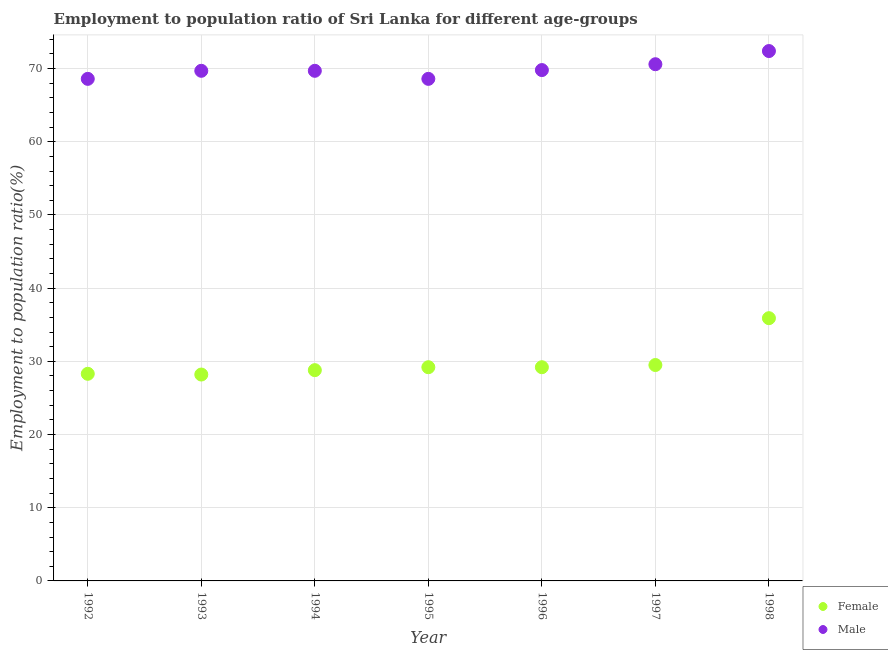How many different coloured dotlines are there?
Provide a short and direct response. 2. What is the employment to population ratio(male) in 1998?
Offer a terse response. 72.4. Across all years, what is the maximum employment to population ratio(female)?
Provide a succinct answer. 35.9. Across all years, what is the minimum employment to population ratio(female)?
Your answer should be compact. 28.2. In which year was the employment to population ratio(male) minimum?
Provide a succinct answer. 1992. What is the total employment to population ratio(male) in the graph?
Ensure brevity in your answer.  489.4. What is the difference between the employment to population ratio(male) in 1996 and that in 1998?
Give a very brief answer. -2.6. What is the difference between the employment to population ratio(female) in 1998 and the employment to population ratio(male) in 1995?
Your answer should be compact. -32.7. What is the average employment to population ratio(female) per year?
Provide a succinct answer. 29.87. In the year 1993, what is the difference between the employment to population ratio(female) and employment to population ratio(male)?
Offer a very short reply. -41.5. What is the ratio of the employment to population ratio(male) in 1993 to that in 1998?
Keep it short and to the point. 0.96. Is the employment to population ratio(male) in 1997 less than that in 1998?
Offer a very short reply. Yes. What is the difference between the highest and the second highest employment to population ratio(male)?
Make the answer very short. 1.8. What is the difference between the highest and the lowest employment to population ratio(male)?
Your response must be concise. 3.8. Is the sum of the employment to population ratio(female) in 1994 and 1995 greater than the maximum employment to population ratio(male) across all years?
Provide a succinct answer. No. Does the employment to population ratio(female) monotonically increase over the years?
Give a very brief answer. No. Is the employment to population ratio(female) strictly less than the employment to population ratio(male) over the years?
Provide a succinct answer. Yes. What is the difference between two consecutive major ticks on the Y-axis?
Provide a short and direct response. 10. Are the values on the major ticks of Y-axis written in scientific E-notation?
Your answer should be very brief. No. Does the graph contain any zero values?
Your answer should be compact. No. Does the graph contain grids?
Provide a short and direct response. Yes. Where does the legend appear in the graph?
Keep it short and to the point. Bottom right. How are the legend labels stacked?
Offer a very short reply. Vertical. What is the title of the graph?
Ensure brevity in your answer.  Employment to population ratio of Sri Lanka for different age-groups. Does "All education staff compensation" appear as one of the legend labels in the graph?
Your answer should be compact. No. What is the label or title of the X-axis?
Give a very brief answer. Year. What is the label or title of the Y-axis?
Give a very brief answer. Employment to population ratio(%). What is the Employment to population ratio(%) in Female in 1992?
Provide a succinct answer. 28.3. What is the Employment to population ratio(%) in Male in 1992?
Your response must be concise. 68.6. What is the Employment to population ratio(%) in Female in 1993?
Offer a terse response. 28.2. What is the Employment to population ratio(%) of Male in 1993?
Your response must be concise. 69.7. What is the Employment to population ratio(%) in Female in 1994?
Ensure brevity in your answer.  28.8. What is the Employment to population ratio(%) of Male in 1994?
Keep it short and to the point. 69.7. What is the Employment to population ratio(%) in Female in 1995?
Ensure brevity in your answer.  29.2. What is the Employment to population ratio(%) in Male in 1995?
Provide a short and direct response. 68.6. What is the Employment to population ratio(%) in Female in 1996?
Ensure brevity in your answer.  29.2. What is the Employment to population ratio(%) in Male in 1996?
Your response must be concise. 69.8. What is the Employment to population ratio(%) in Female in 1997?
Offer a terse response. 29.5. What is the Employment to population ratio(%) of Male in 1997?
Make the answer very short. 70.6. What is the Employment to population ratio(%) in Female in 1998?
Provide a succinct answer. 35.9. What is the Employment to population ratio(%) of Male in 1998?
Provide a short and direct response. 72.4. Across all years, what is the maximum Employment to population ratio(%) in Female?
Provide a succinct answer. 35.9. Across all years, what is the maximum Employment to population ratio(%) in Male?
Keep it short and to the point. 72.4. Across all years, what is the minimum Employment to population ratio(%) of Female?
Keep it short and to the point. 28.2. Across all years, what is the minimum Employment to population ratio(%) of Male?
Provide a short and direct response. 68.6. What is the total Employment to population ratio(%) of Female in the graph?
Keep it short and to the point. 209.1. What is the total Employment to population ratio(%) of Male in the graph?
Provide a succinct answer. 489.4. What is the difference between the Employment to population ratio(%) of Female in 1992 and that in 1993?
Your answer should be compact. 0.1. What is the difference between the Employment to population ratio(%) of Male in 1992 and that in 1993?
Offer a very short reply. -1.1. What is the difference between the Employment to population ratio(%) of Female in 1992 and that in 1994?
Offer a terse response. -0.5. What is the difference between the Employment to population ratio(%) of Female in 1992 and that in 1996?
Make the answer very short. -0.9. What is the difference between the Employment to population ratio(%) in Female in 1992 and that in 1997?
Provide a succinct answer. -1.2. What is the difference between the Employment to population ratio(%) of Male in 1992 and that in 1997?
Provide a succinct answer. -2. What is the difference between the Employment to population ratio(%) in Female in 1992 and that in 1998?
Keep it short and to the point. -7.6. What is the difference between the Employment to population ratio(%) of Female in 1993 and that in 1995?
Provide a succinct answer. -1. What is the difference between the Employment to population ratio(%) in Male in 1993 and that in 1996?
Offer a terse response. -0.1. What is the difference between the Employment to population ratio(%) in Male in 1993 and that in 1997?
Provide a short and direct response. -0.9. What is the difference between the Employment to population ratio(%) of Female in 1993 and that in 1998?
Ensure brevity in your answer.  -7.7. What is the difference between the Employment to population ratio(%) of Male in 1993 and that in 1998?
Keep it short and to the point. -2.7. What is the difference between the Employment to population ratio(%) in Male in 1994 and that in 1995?
Keep it short and to the point. 1.1. What is the difference between the Employment to population ratio(%) in Male in 1994 and that in 1997?
Your answer should be compact. -0.9. What is the difference between the Employment to population ratio(%) of Male in 1994 and that in 1998?
Offer a very short reply. -2.7. What is the difference between the Employment to population ratio(%) of Female in 1995 and that in 1997?
Provide a succinct answer. -0.3. What is the difference between the Employment to population ratio(%) of Female in 1995 and that in 1998?
Provide a short and direct response. -6.7. What is the difference between the Employment to population ratio(%) of Male in 1995 and that in 1998?
Make the answer very short. -3.8. What is the difference between the Employment to population ratio(%) of Male in 1996 and that in 1997?
Offer a terse response. -0.8. What is the difference between the Employment to population ratio(%) of Male in 1996 and that in 1998?
Offer a terse response. -2.6. What is the difference between the Employment to population ratio(%) of Male in 1997 and that in 1998?
Your response must be concise. -1.8. What is the difference between the Employment to population ratio(%) of Female in 1992 and the Employment to population ratio(%) of Male in 1993?
Give a very brief answer. -41.4. What is the difference between the Employment to population ratio(%) in Female in 1992 and the Employment to population ratio(%) in Male in 1994?
Keep it short and to the point. -41.4. What is the difference between the Employment to population ratio(%) of Female in 1992 and the Employment to population ratio(%) of Male in 1995?
Offer a terse response. -40.3. What is the difference between the Employment to population ratio(%) in Female in 1992 and the Employment to population ratio(%) in Male in 1996?
Provide a short and direct response. -41.5. What is the difference between the Employment to population ratio(%) in Female in 1992 and the Employment to population ratio(%) in Male in 1997?
Make the answer very short. -42.3. What is the difference between the Employment to population ratio(%) of Female in 1992 and the Employment to population ratio(%) of Male in 1998?
Make the answer very short. -44.1. What is the difference between the Employment to population ratio(%) in Female in 1993 and the Employment to population ratio(%) in Male in 1994?
Ensure brevity in your answer.  -41.5. What is the difference between the Employment to population ratio(%) of Female in 1993 and the Employment to population ratio(%) of Male in 1995?
Offer a terse response. -40.4. What is the difference between the Employment to population ratio(%) in Female in 1993 and the Employment to population ratio(%) in Male in 1996?
Make the answer very short. -41.6. What is the difference between the Employment to population ratio(%) of Female in 1993 and the Employment to population ratio(%) of Male in 1997?
Keep it short and to the point. -42.4. What is the difference between the Employment to population ratio(%) in Female in 1993 and the Employment to population ratio(%) in Male in 1998?
Your response must be concise. -44.2. What is the difference between the Employment to population ratio(%) of Female in 1994 and the Employment to population ratio(%) of Male in 1995?
Make the answer very short. -39.8. What is the difference between the Employment to population ratio(%) of Female in 1994 and the Employment to population ratio(%) of Male in 1996?
Offer a terse response. -41. What is the difference between the Employment to population ratio(%) of Female in 1994 and the Employment to population ratio(%) of Male in 1997?
Provide a succinct answer. -41.8. What is the difference between the Employment to population ratio(%) in Female in 1994 and the Employment to population ratio(%) in Male in 1998?
Your answer should be very brief. -43.6. What is the difference between the Employment to population ratio(%) in Female in 1995 and the Employment to population ratio(%) in Male in 1996?
Your answer should be compact. -40.6. What is the difference between the Employment to population ratio(%) of Female in 1995 and the Employment to population ratio(%) of Male in 1997?
Ensure brevity in your answer.  -41.4. What is the difference between the Employment to population ratio(%) of Female in 1995 and the Employment to population ratio(%) of Male in 1998?
Keep it short and to the point. -43.2. What is the difference between the Employment to population ratio(%) in Female in 1996 and the Employment to population ratio(%) in Male in 1997?
Offer a very short reply. -41.4. What is the difference between the Employment to population ratio(%) in Female in 1996 and the Employment to population ratio(%) in Male in 1998?
Offer a very short reply. -43.2. What is the difference between the Employment to population ratio(%) of Female in 1997 and the Employment to population ratio(%) of Male in 1998?
Your answer should be very brief. -42.9. What is the average Employment to population ratio(%) of Female per year?
Offer a terse response. 29.87. What is the average Employment to population ratio(%) in Male per year?
Your response must be concise. 69.91. In the year 1992, what is the difference between the Employment to population ratio(%) in Female and Employment to population ratio(%) in Male?
Your response must be concise. -40.3. In the year 1993, what is the difference between the Employment to population ratio(%) in Female and Employment to population ratio(%) in Male?
Your response must be concise. -41.5. In the year 1994, what is the difference between the Employment to population ratio(%) in Female and Employment to population ratio(%) in Male?
Your answer should be very brief. -40.9. In the year 1995, what is the difference between the Employment to population ratio(%) of Female and Employment to population ratio(%) of Male?
Offer a terse response. -39.4. In the year 1996, what is the difference between the Employment to population ratio(%) of Female and Employment to population ratio(%) of Male?
Provide a short and direct response. -40.6. In the year 1997, what is the difference between the Employment to population ratio(%) in Female and Employment to population ratio(%) in Male?
Keep it short and to the point. -41.1. In the year 1998, what is the difference between the Employment to population ratio(%) in Female and Employment to population ratio(%) in Male?
Provide a succinct answer. -36.5. What is the ratio of the Employment to population ratio(%) in Female in 1992 to that in 1993?
Make the answer very short. 1. What is the ratio of the Employment to population ratio(%) in Male in 1992 to that in 1993?
Offer a terse response. 0.98. What is the ratio of the Employment to population ratio(%) in Female in 1992 to that in 1994?
Offer a terse response. 0.98. What is the ratio of the Employment to population ratio(%) in Male in 1992 to that in 1994?
Ensure brevity in your answer.  0.98. What is the ratio of the Employment to population ratio(%) in Female in 1992 to that in 1995?
Make the answer very short. 0.97. What is the ratio of the Employment to population ratio(%) in Male in 1992 to that in 1995?
Your response must be concise. 1. What is the ratio of the Employment to population ratio(%) in Female in 1992 to that in 1996?
Offer a very short reply. 0.97. What is the ratio of the Employment to population ratio(%) in Male in 1992 to that in 1996?
Keep it short and to the point. 0.98. What is the ratio of the Employment to population ratio(%) in Female in 1992 to that in 1997?
Provide a succinct answer. 0.96. What is the ratio of the Employment to population ratio(%) in Male in 1992 to that in 1997?
Your answer should be compact. 0.97. What is the ratio of the Employment to population ratio(%) of Female in 1992 to that in 1998?
Make the answer very short. 0.79. What is the ratio of the Employment to population ratio(%) of Male in 1992 to that in 1998?
Make the answer very short. 0.95. What is the ratio of the Employment to population ratio(%) of Female in 1993 to that in 1994?
Offer a terse response. 0.98. What is the ratio of the Employment to population ratio(%) of Male in 1993 to that in 1994?
Keep it short and to the point. 1. What is the ratio of the Employment to population ratio(%) in Female in 1993 to that in 1995?
Your response must be concise. 0.97. What is the ratio of the Employment to population ratio(%) of Female in 1993 to that in 1996?
Provide a succinct answer. 0.97. What is the ratio of the Employment to population ratio(%) in Female in 1993 to that in 1997?
Offer a terse response. 0.96. What is the ratio of the Employment to population ratio(%) of Male in 1993 to that in 1997?
Make the answer very short. 0.99. What is the ratio of the Employment to population ratio(%) of Female in 1993 to that in 1998?
Your answer should be very brief. 0.79. What is the ratio of the Employment to population ratio(%) of Male in 1993 to that in 1998?
Offer a very short reply. 0.96. What is the ratio of the Employment to population ratio(%) in Female in 1994 to that in 1995?
Make the answer very short. 0.99. What is the ratio of the Employment to population ratio(%) of Male in 1994 to that in 1995?
Your answer should be very brief. 1.02. What is the ratio of the Employment to population ratio(%) of Female in 1994 to that in 1996?
Offer a terse response. 0.99. What is the ratio of the Employment to population ratio(%) in Male in 1994 to that in 1996?
Offer a very short reply. 1. What is the ratio of the Employment to population ratio(%) in Female in 1994 to that in 1997?
Your answer should be very brief. 0.98. What is the ratio of the Employment to population ratio(%) in Male in 1994 to that in 1997?
Ensure brevity in your answer.  0.99. What is the ratio of the Employment to population ratio(%) of Female in 1994 to that in 1998?
Provide a short and direct response. 0.8. What is the ratio of the Employment to population ratio(%) of Male in 1994 to that in 1998?
Your answer should be compact. 0.96. What is the ratio of the Employment to population ratio(%) in Male in 1995 to that in 1996?
Make the answer very short. 0.98. What is the ratio of the Employment to population ratio(%) of Female in 1995 to that in 1997?
Provide a short and direct response. 0.99. What is the ratio of the Employment to population ratio(%) of Male in 1995 to that in 1997?
Provide a short and direct response. 0.97. What is the ratio of the Employment to population ratio(%) of Female in 1995 to that in 1998?
Provide a short and direct response. 0.81. What is the ratio of the Employment to population ratio(%) of Male in 1995 to that in 1998?
Ensure brevity in your answer.  0.95. What is the ratio of the Employment to population ratio(%) of Female in 1996 to that in 1997?
Give a very brief answer. 0.99. What is the ratio of the Employment to population ratio(%) in Male in 1996 to that in 1997?
Offer a very short reply. 0.99. What is the ratio of the Employment to population ratio(%) in Female in 1996 to that in 1998?
Provide a succinct answer. 0.81. What is the ratio of the Employment to population ratio(%) of Male in 1996 to that in 1998?
Keep it short and to the point. 0.96. What is the ratio of the Employment to population ratio(%) in Female in 1997 to that in 1998?
Provide a short and direct response. 0.82. What is the ratio of the Employment to population ratio(%) of Male in 1997 to that in 1998?
Provide a succinct answer. 0.98. What is the difference between the highest and the second highest Employment to population ratio(%) in Male?
Make the answer very short. 1.8. What is the difference between the highest and the lowest Employment to population ratio(%) of Female?
Offer a very short reply. 7.7. 